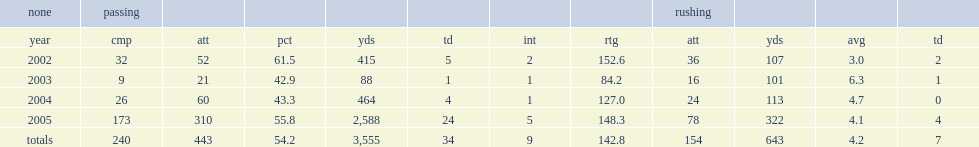How many passing yards did shockley get in 2002? 415.0. 